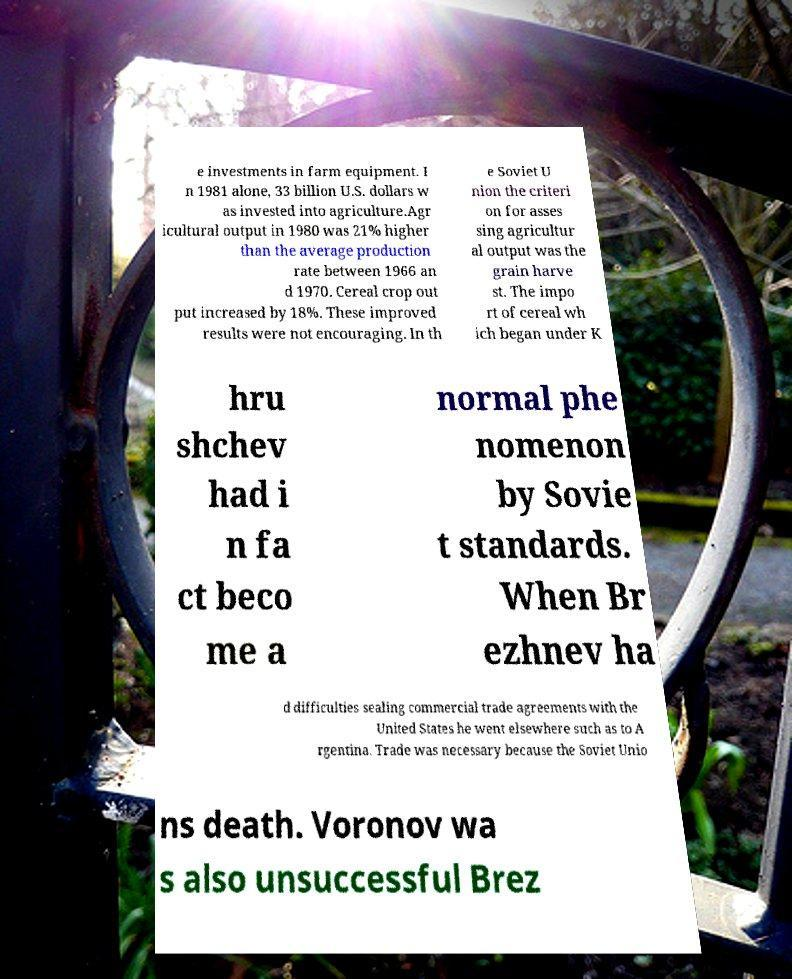Please identify and transcribe the text found in this image. e investments in farm equipment. I n 1981 alone, 33 billion U.S. dollars w as invested into agriculture.Agr icultural output in 1980 was 21% higher than the average production rate between 1966 an d 1970. Cereal crop out put increased by 18%. These improved results were not encouraging. In th e Soviet U nion the criteri on for asses sing agricultur al output was the grain harve st. The impo rt of cereal wh ich began under K hru shchev had i n fa ct beco me a normal phe nomenon by Sovie t standards. When Br ezhnev ha d difficulties sealing commercial trade agreements with the United States he went elsewhere such as to A rgentina. Trade was necessary because the Soviet Unio ns death. Voronov wa s also unsuccessful Brez 